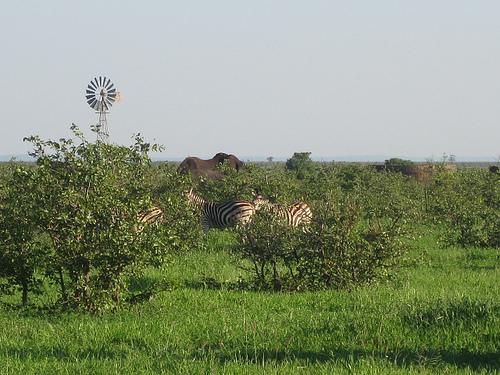Is the sun shining bright?
Give a very brief answer. Yes. Is there a windmill?
Be succinct. Yes. What time was the picture taken?
Quick response, please. Daytime. Is this farming country?
Write a very short answer. Yes. How many chairs do you see?
Quick response, please. 0. Where was the pic taken?
Write a very short answer. Africa. What kind of animals are these?
Keep it brief. Zebras. Where are the animals?
Write a very short answer. Behind bushes. What animals are in the distance?
Answer briefly. Zebra. Are these birds?
Answer briefly. No. What is in the grass?
Keep it brief. Zebras. What is the farthest animal?
Answer briefly. Elephant. What is the tallest part of the image?
Answer briefly. Windmill. Are there any rocks in the field?
Quick response, please. No. 